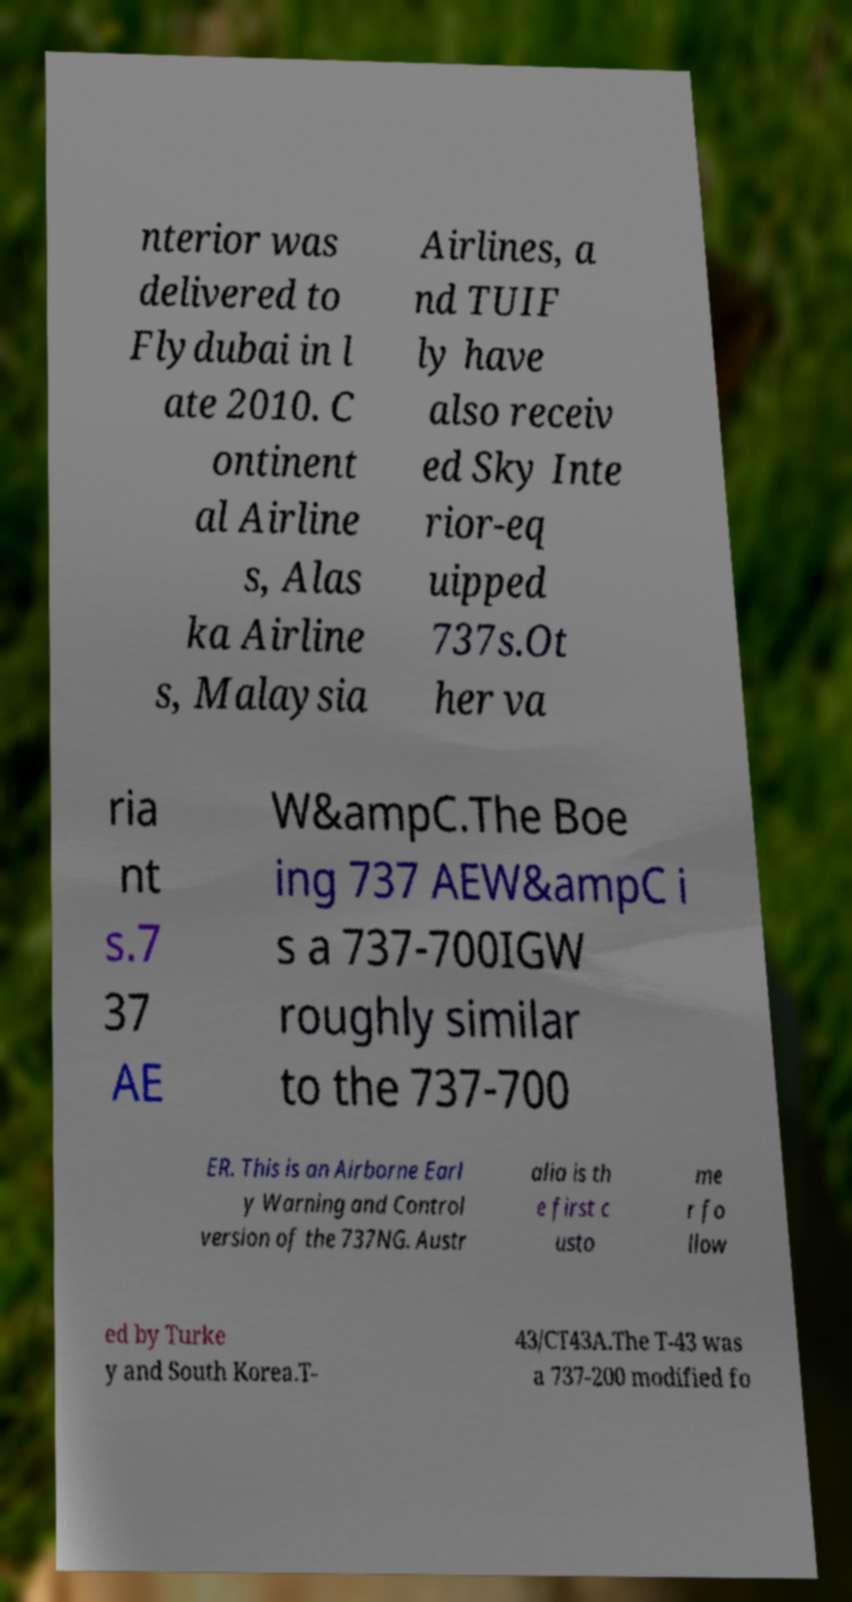Could you assist in decoding the text presented in this image and type it out clearly? nterior was delivered to Flydubai in l ate 2010. C ontinent al Airline s, Alas ka Airline s, Malaysia Airlines, a nd TUIF ly have also receiv ed Sky Inte rior-eq uipped 737s.Ot her va ria nt s.7 37 AE W&ampC.The Boe ing 737 AEW&ampC i s a 737-700IGW roughly similar to the 737-700 ER. This is an Airborne Earl y Warning and Control version of the 737NG. Austr alia is th e first c usto me r fo llow ed by Turke y and South Korea.T- 43/CT43A.The T-43 was a 737-200 modified fo 